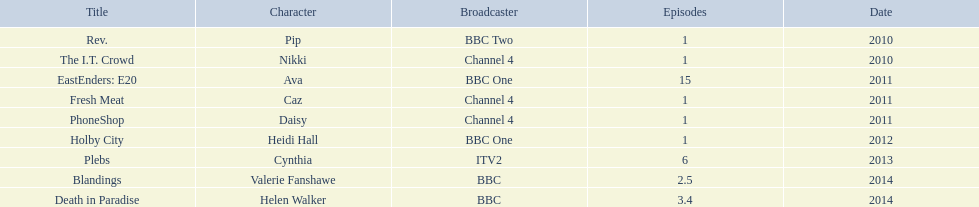What roles did she play? Pip, Nikki, Ava, Caz, Daisy, Heidi Hall, Cynthia, Valerie Fanshawe, Helen Walker. On which broadcasters? BBC Two, Channel 4, BBC One, Channel 4, Channel 4, BBC One, ITV2, BBC, BBC. Which roles did she play for itv2? Cynthia. 